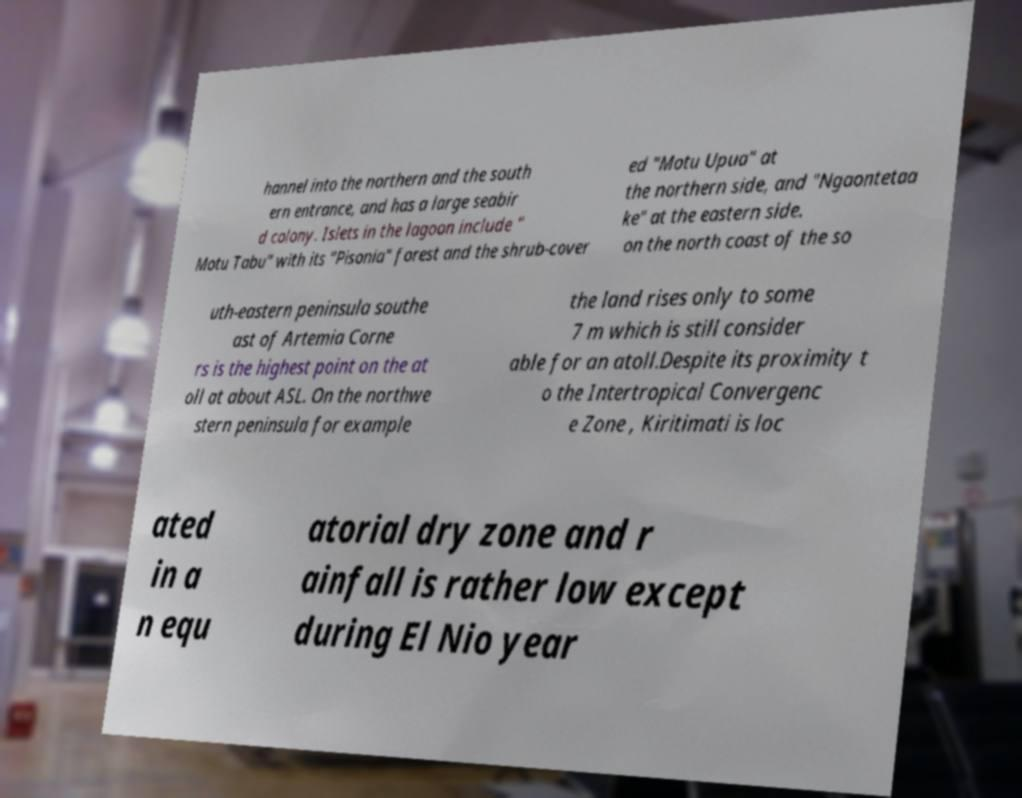Can you accurately transcribe the text from the provided image for me? hannel into the northern and the south ern entrance, and has a large seabir d colony. Islets in the lagoon include " Motu Tabu" with its "Pisonia" forest and the shrub-cover ed "Motu Upua" at the northern side, and "Ngaontetaa ke" at the eastern side. on the north coast of the so uth-eastern peninsula southe ast of Artemia Corne rs is the highest point on the at oll at about ASL. On the northwe stern peninsula for example the land rises only to some 7 m which is still consider able for an atoll.Despite its proximity t o the Intertropical Convergenc e Zone , Kiritimati is loc ated in a n equ atorial dry zone and r ainfall is rather low except during El Nio year 